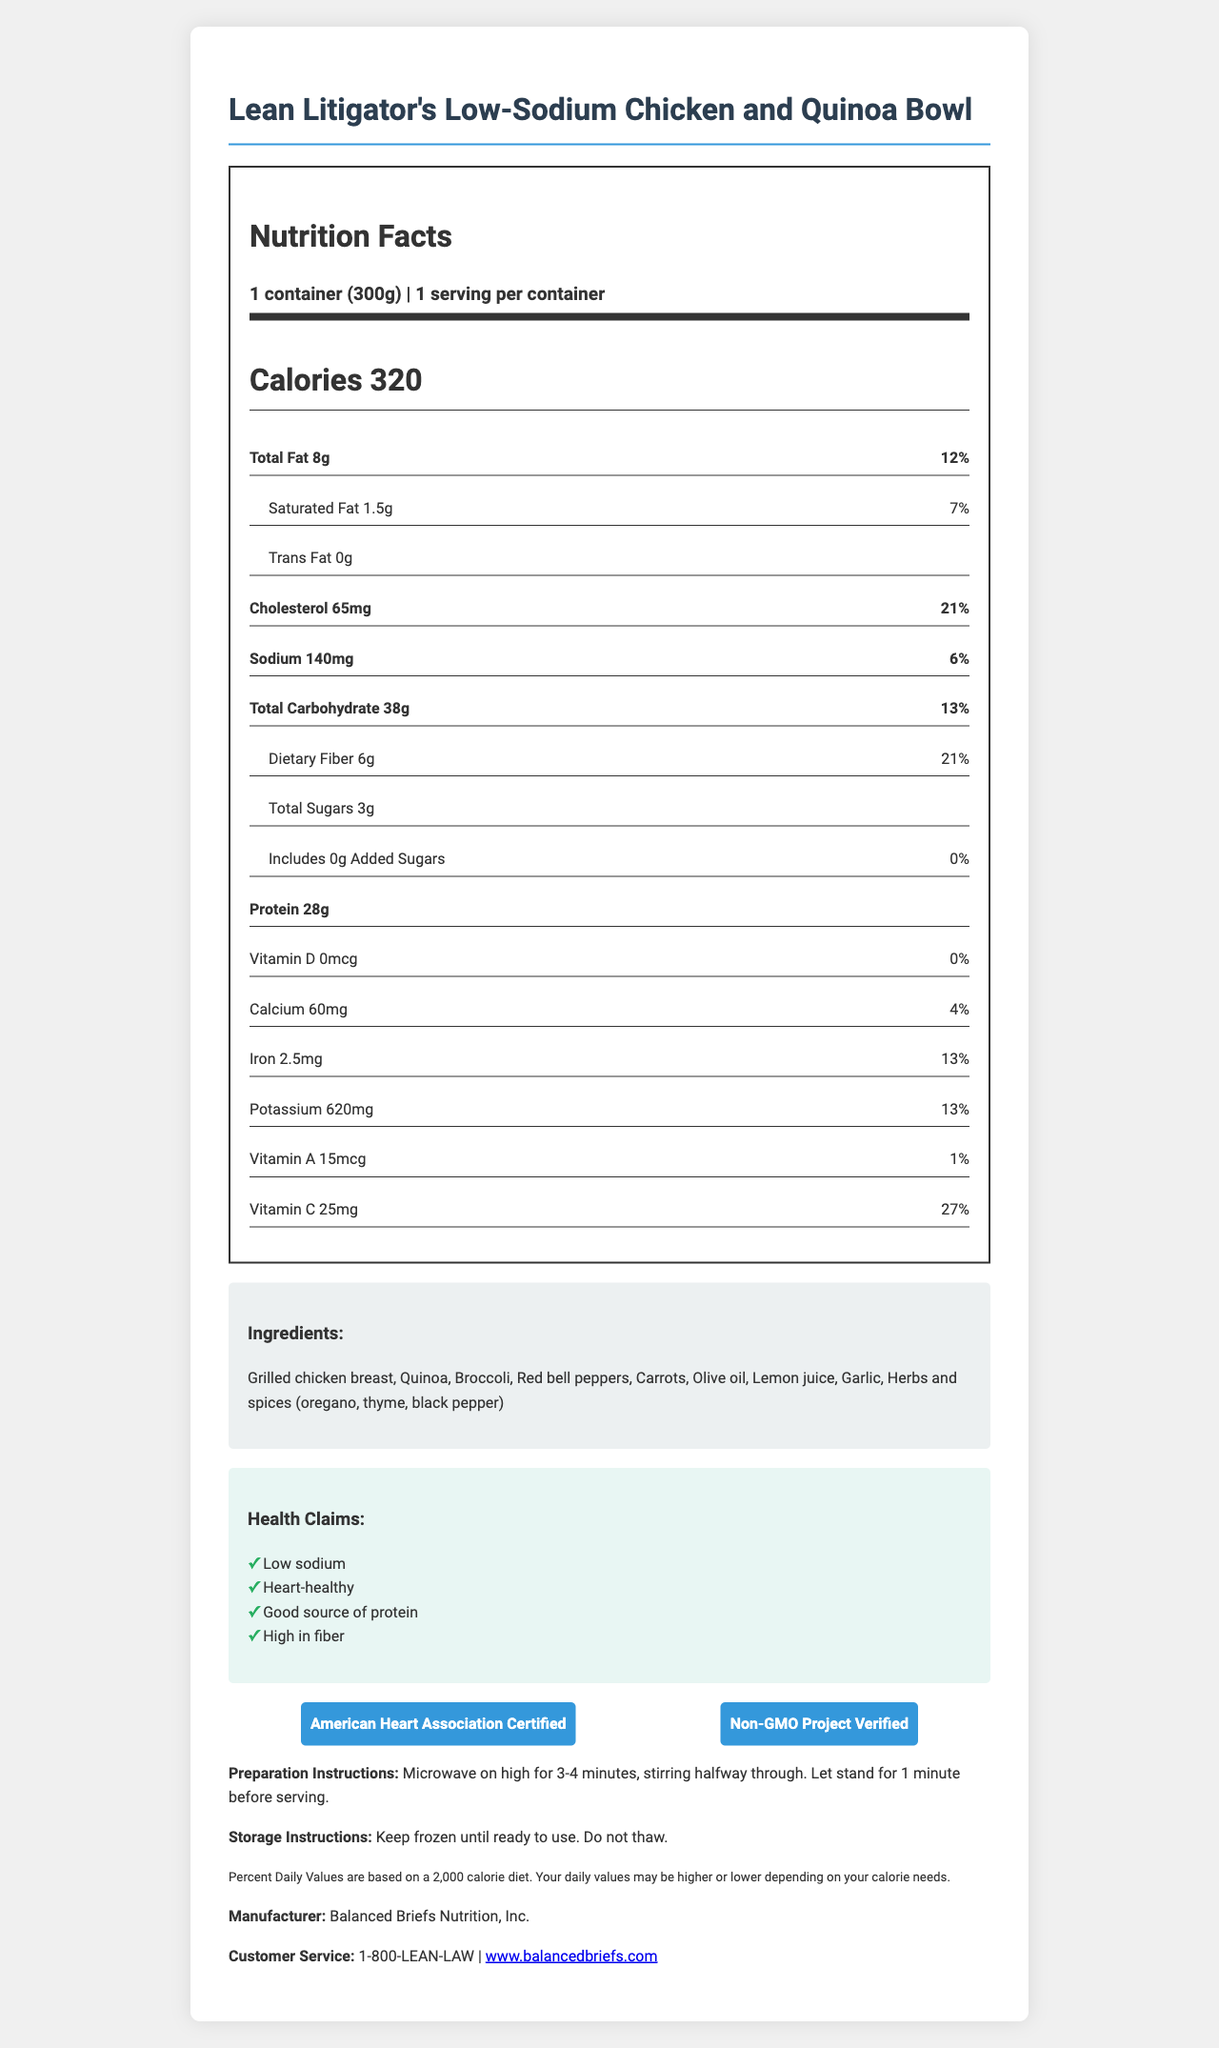what is the product name? The product name is stated at the top of the document.
Answer: Lean Litigator's Low-Sodium Chicken and Quinoa Bowl what is the serving size? The serving size is specified in the Nutrition Facts section.
Answer: 1 container (300g) how many calories are in one serving? The number of calories per serving is listed as 320 in the Nutrition Facts section.
Answer: 320 calories which organization certified this product as heart-healthy? The American Heart Association Certified label is mentioned in the certifications section.
Answer: American Heart Association what is the total amount of protein in this product? The amount of protein is listed as 28g in the Nutrition Facts section.
Answer: 28 grams how should this product be prepared? The preparation instructions detail that the product should be microwaved on high for 3-4 minutes, stirring halfway through, and then allowed to stand for 1 minute.
Answer: Microwave on high for 3-4 minutes, stirring halfway through. Let stand for 1 minute before serving. does this product contain any trans fat? The Nutrition Facts section states that the trans fat content is 0g.
Answer: No what is the sodium content of this product? A. 140mg B. 230mg C. 340mg D. 450mg The sodium content is listed as 140mg in the Nutrition Facts section.
Answer: A. 140mg which of the following is an ingredient of this product? I. Spinach II. Red bell peppers III. Chicken broth Red bell peppers are listed as one of the ingredients while spinach and chicken broth are not.
Answer: II. Red bell peppers is this product GMO-free? The certifications section mentions "Non-GMO Project Verified".
Answer: Yes summarize the main features of the product. The summary encapsulates the main attributes of the product, including its nutritional content, health certifications, ingredients, preparation instructions, and manufacturer details.
Answer: The Lean Litigator's Low-Sodium Chicken and Quinoa Bowl is a heart-healthy frozen dinner with a low sodium content, providing 320 calories per serving. It is rich in protein and fiber, contains no trans fat, and is certified by the American Heart Association and Non-GMO Project. The product includes ingredients like grilled chicken breast, quinoa, and vegetables, and is microwave-prepared. It is manufactured by Balanced Briefs Nutrition, Inc. what are the allergens present in this product? The allergens section explicitly states that there are no allergens present in this product.
Answer: None is the total carbohydrate amount higher than the dietary fiber amount in this product? The total carbohydrate amount is 38g, which is higher than the dietary fiber amount of 6g, as listed in the Nutrition Facts section.
Answer: Yes what is the potassium percentage of the daily value? The potassium content is listed as 620mg, which corresponds to 13% of the daily value.
Answer: 13% how much sugar is added to this product? The added sugars are listed as 0g in the Nutrition Facts section.
Answer: 0 grams can the preparation instructions be used for cooking this product in an oven? The document only provides microwave-preparation instructions and does not specify if the product can be prepared in an oven.
Answer: Not enough information 